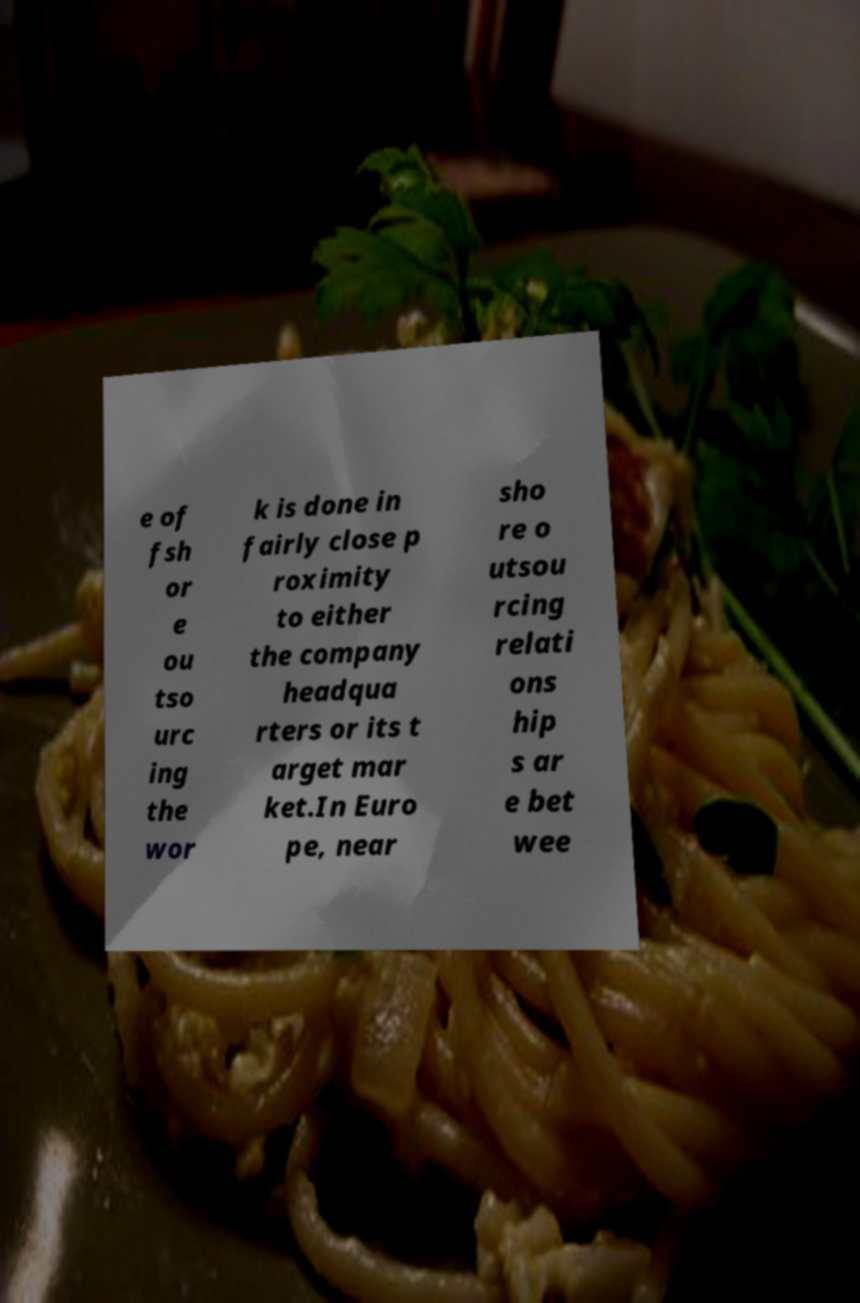I need the written content from this picture converted into text. Can you do that? e of fsh or e ou tso urc ing the wor k is done in fairly close p roximity to either the company headqua rters or its t arget mar ket.In Euro pe, near sho re o utsou rcing relati ons hip s ar e bet wee 